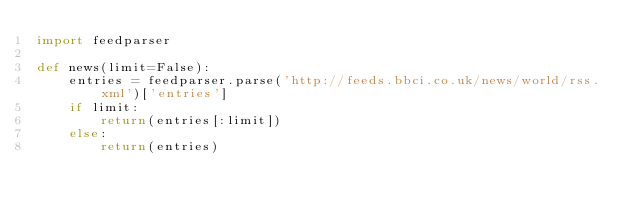Convert code to text. <code><loc_0><loc_0><loc_500><loc_500><_Python_>import feedparser

def news(limit=False):
    entries = feedparser.parse('http://feeds.bbci.co.uk/news/world/rss.xml')['entries']
    if limit:
        return(entries[:limit])
    else:
        return(entries)</code> 